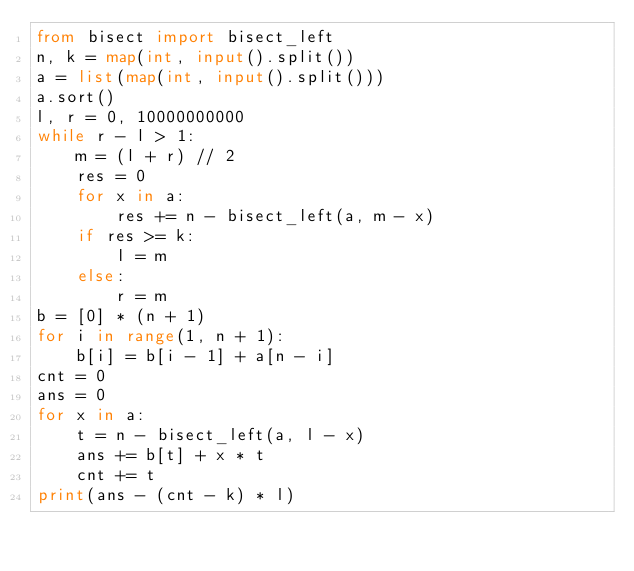Convert code to text. <code><loc_0><loc_0><loc_500><loc_500><_Python_>from bisect import bisect_left
n, k = map(int, input().split())
a = list(map(int, input().split()))
a.sort()
l, r = 0, 10000000000
while r - l > 1:
    m = (l + r) // 2
    res = 0
    for x in a:
        res += n - bisect_left(a, m - x)
    if res >= k:
        l = m
    else:
        r = m
b = [0] * (n + 1)
for i in range(1, n + 1):
    b[i] = b[i - 1] + a[n - i]
cnt = 0
ans = 0
for x in a:
    t = n - bisect_left(a, l - x)
    ans += b[t] + x * t
    cnt += t
print(ans - (cnt - k) * l)
</code> 